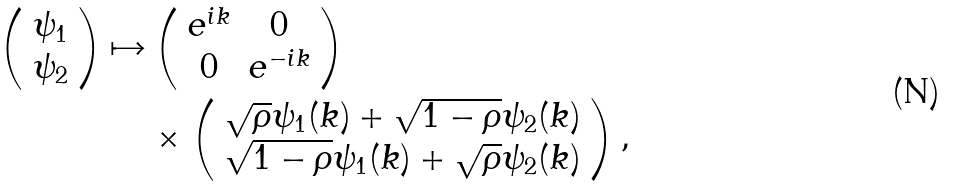<formula> <loc_0><loc_0><loc_500><loc_500>\left ( \begin{array} { c } \psi _ { 1 } \\ \psi _ { 2 } \end{array} \right ) \mapsto & \left ( \begin{array} { c c } e ^ { i k } & 0 \\ 0 & e ^ { - i k } \end{array} \right ) \\ & \times \left ( \begin{array} { c } \sqrt { \rho } \psi _ { 1 } ( k ) + \sqrt { 1 - \rho } \psi _ { 2 } ( k ) \\ \sqrt { 1 - \rho } \psi _ { 1 } ( k ) + \sqrt { \rho } \psi _ { 2 } ( k ) \end{array} \right ) ,</formula> 